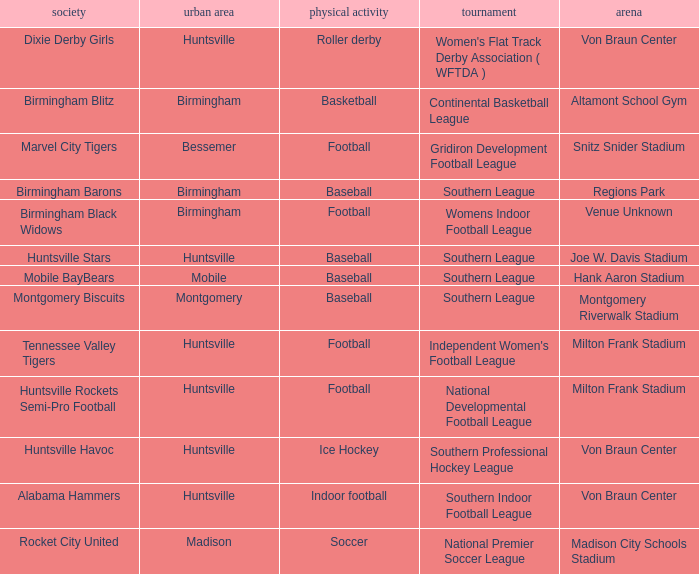Which venue hosted the Dixie Derby Girls? Von Braun Center. 